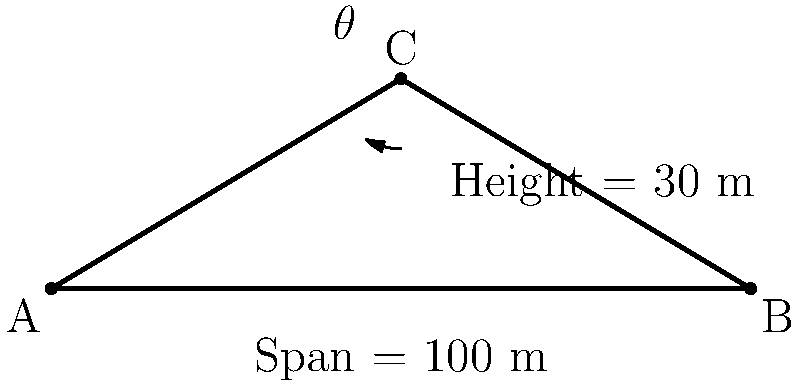As a retired engineer, you're asked to consult on a bridge project. The bridge has a span of 100 meters and a truss height of 30 meters at its peak. What is the optimal angle $\theta$ (in degrees) for the truss members connecting the peak to the supports for maximum structural efficiency? To determine the optimal angle for the bridge truss, we'll follow these steps:

1) In a truss bridge, the optimal angle for maximum structural efficiency is typically around 45°. However, we need to calculate the actual angle based on the given dimensions.

2) We can use the tangent function to find this angle. The tangent of the angle is the ratio of the opposite side (height) to the adjacent side (half of the span).

3) The height is 30 meters, and half of the span is 50 meters (100/2).

4) Let's set up the equation:

   $$\tan(\theta) = \frac{\text{opposite}}{\text{adjacent}} = \frac{\text{height}}{\text{half span}} = \frac{30}{50}$$

5) To solve for $\theta$, we need to use the inverse tangent (arctan or $\tan^{-1}$):

   $$\theta = \tan^{-1}\left(\frac{30}{50}\right)$$

6) Using a calculator or computer:

   $$\theta \approx 30.96^\circ$$

7) Rounding to the nearest degree:

   $$\theta \approx 31^\circ$$

This angle is close to the ideal 45°, providing a good balance between vertical and horizontal forces in the truss members.
Answer: 31° 